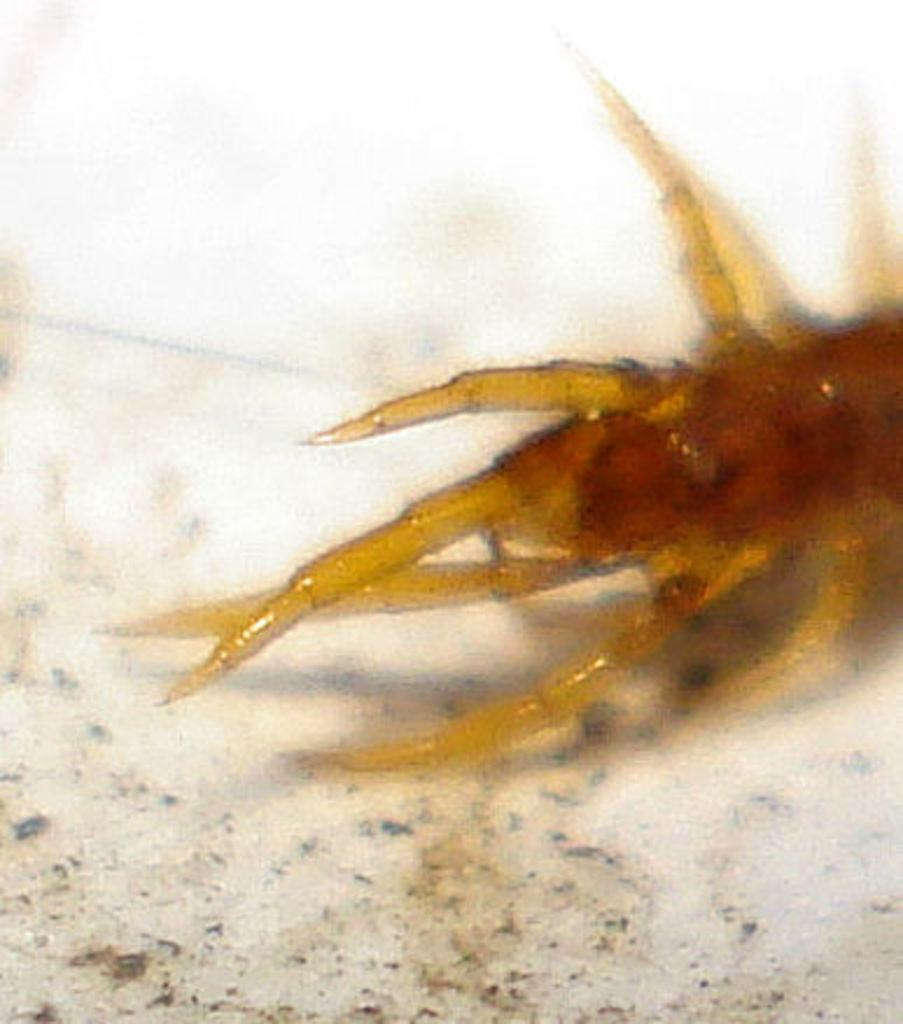What is present on the ground in the image? There is an insect on the ground in the image. Can you describe the insect's location more specifically? The insect is on the ground, but no further details about its exact position are provided. Based on the lighting in the image, when do you think it was taken? The image was likely taken during the day, as there is sufficient light to see the insect clearly. What type of flame can be seen balancing on the insect's back in the image? There is no flame present in the image, and the insect is not balancing anything on its back. 